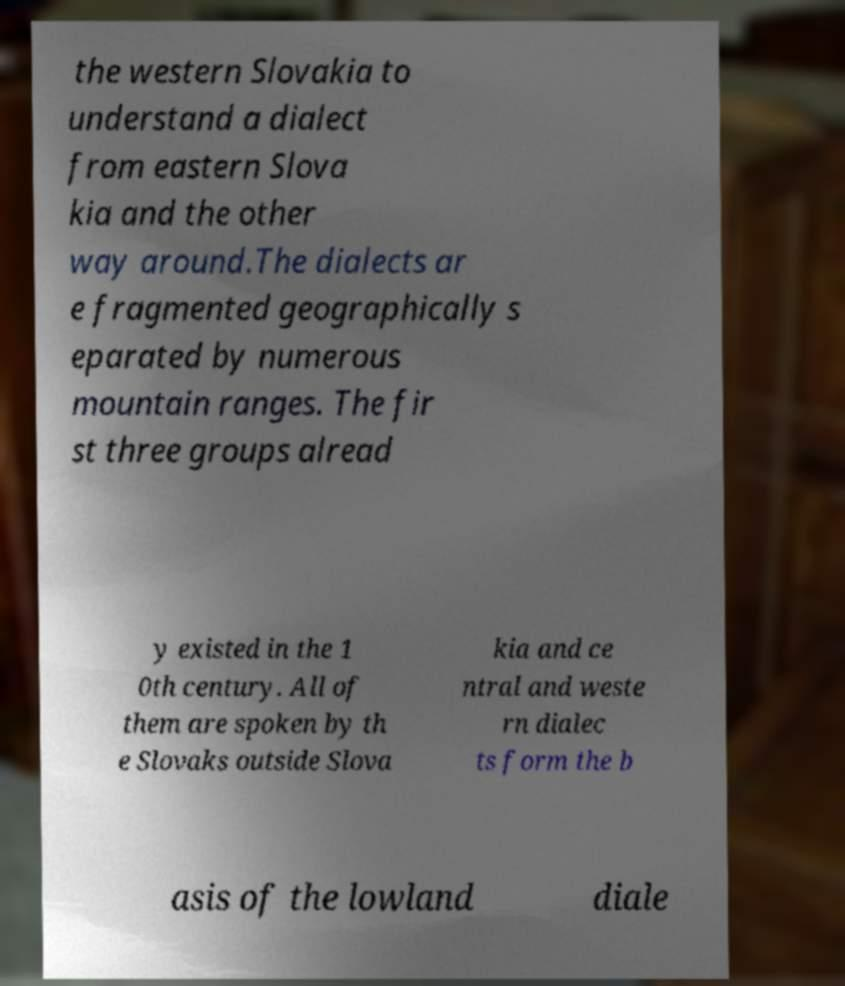What messages or text are displayed in this image? I need them in a readable, typed format. the western Slovakia to understand a dialect from eastern Slova kia and the other way around.The dialects ar e fragmented geographically s eparated by numerous mountain ranges. The fir st three groups alread y existed in the 1 0th century. All of them are spoken by th e Slovaks outside Slova kia and ce ntral and weste rn dialec ts form the b asis of the lowland diale 